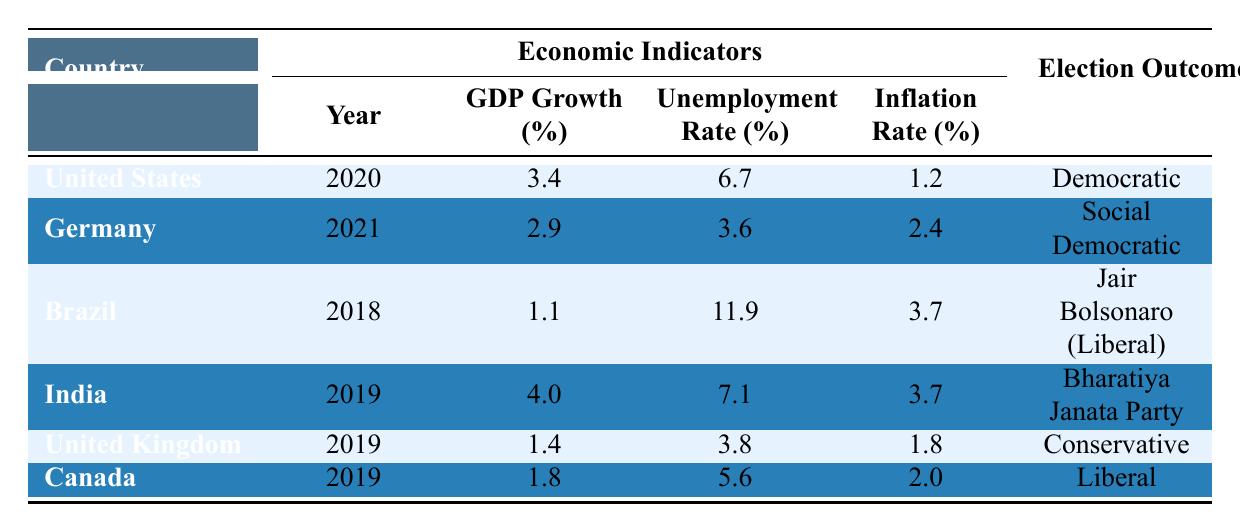What was the GDP growth percentage for Brazil in 2018? The table indicates that Brazil's GDP growth in 2018 is listed under the GDP Growth column. By locating Brazil in the "Country" column and reading across, we find the GDP growth value of 1.1%.
Answer: 1.1% Which country had the highest unemployment rate, and what was the rate? To find the highest unemployment rate, we compare the unemployment rates across all countries. The table shows Brazil with 11.9%, which is greater than any other listed rate. Therefore, Brazil had the highest unemployment rate of 11.9%.
Answer: Brazil; 11.9% Is it true that the United Kingdom had a higher inflation rate than Canada? The inflation rates for the United Kingdom and Canada are listed in the table. The UK's inflation rate is 1.8%, while Canada's is 2.0%. Since 1.8% is less than 2.0%, the statement is false.
Answer: No What is the average GDP growth rate of the countries listed in the table? We sum the GDP growth rates of all countries: (3.4 + 2.9 + 1.1 + 4.0 + 1.4 + 1.8) = 14.6%. There are 6 data points, so to find the average, we divide 14.6 by 6, which results in approximately 2.43%.
Answer: 2.43% Which political party won the election in India in 2019, and how does it relate to its GDP growth that year? According to the table, the Bharatiya Janata Party won the election in India in 2019, and India's GDP growth for that year is 4.0%. This indicates that the party was in power during a relatively higher growth year compared to some other countries listed.
Answer: Bharatiya Janata Party; 4.0% 